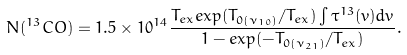<formula> <loc_0><loc_0><loc_500><loc_500>N ( ^ { 1 3 } C O ) = 1 . 5 \times 1 0 ^ { 1 4 } \frac { T _ { e x } e x p ( T _ { 0 ( \nu _ { 1 0 } ) } / T _ { e x } ) \int \tau ^ { 1 3 } ( v ) d v } { 1 - e x p ( - T _ { 0 ( \nu _ { 2 1 } ) } / T _ { e x } ) } .</formula> 